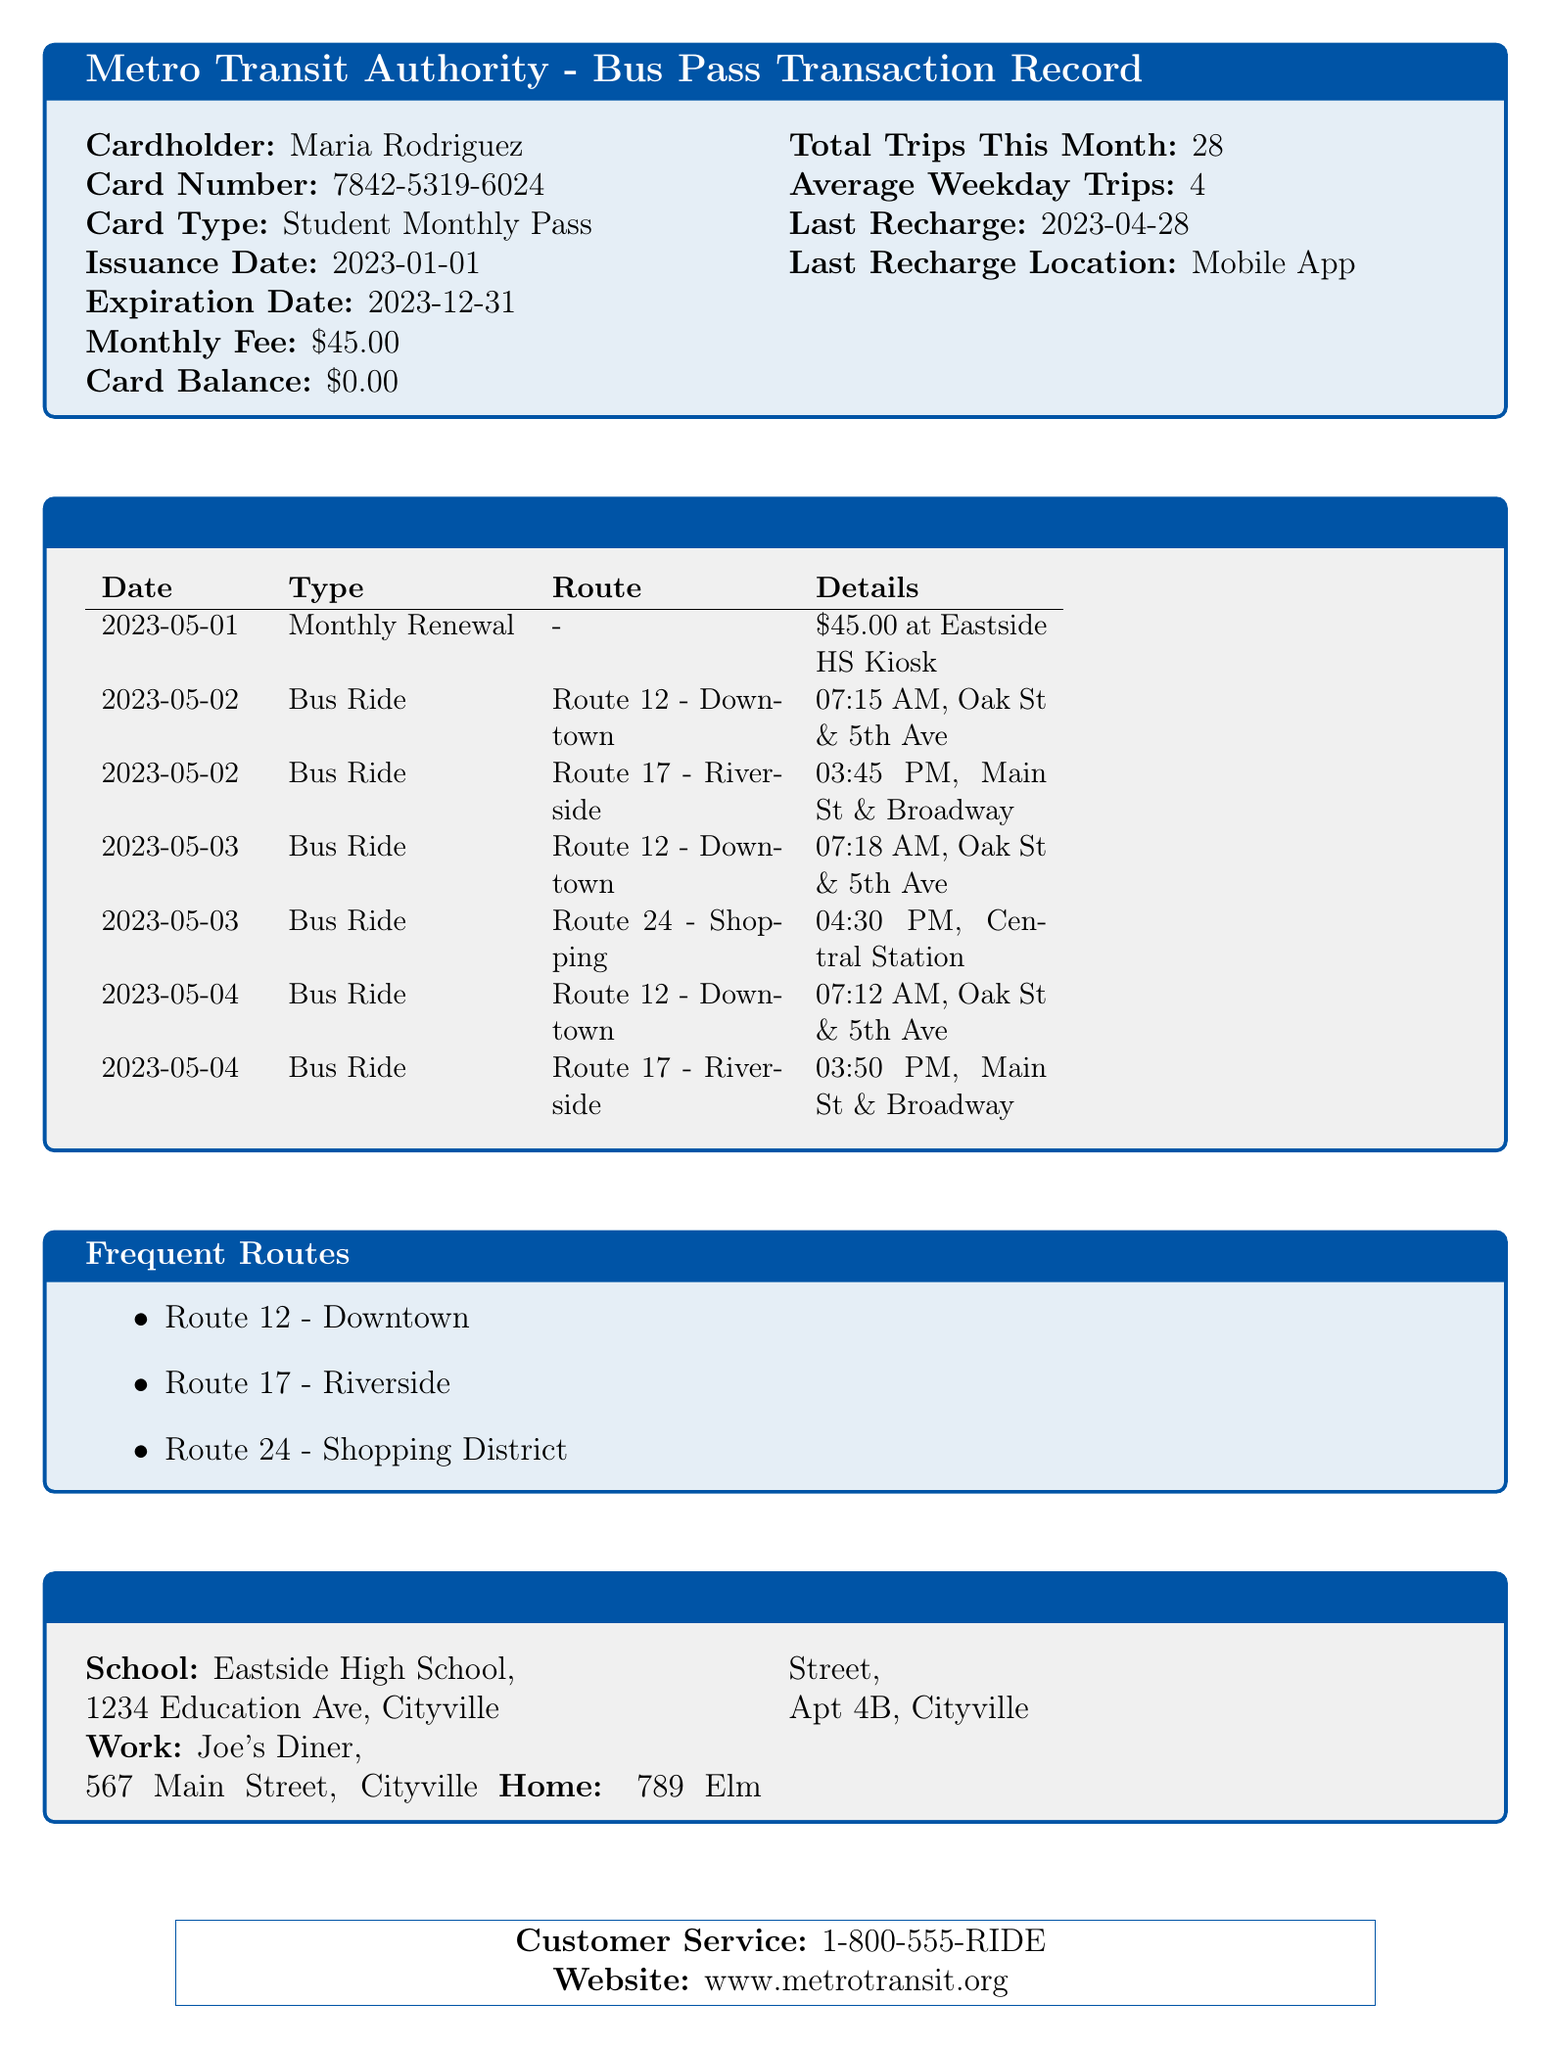what is the cardholder's name? The cardholder's name is listed at the beginning of the document, showing the individual who owns the bus pass.
Answer: Maria Rodriguez what is the monthly fee for the pass? The monthly fee is stated in the financial section of the document, reflecting the cost of the pass.
Answer: $45.00 when was the last recharge made? The last recharge date can be found in the summary box, detailing recent transactions.
Answer: 2023-04-28 how many total trips has Maria taken this month? The total trips this month is summarized in the statistics portion of the document, indicating usage frequency.
Answer: 28 which route is taken to get to school? The route to get to school can be inferred from the frequent routes section of the document that lists the most used routes.
Answer: Route 12 - Downtown what type of card does Maria have? The card type is specifically mentioned in the document, describing the nature of the pass.
Answer: Student Monthly Pass where is Maria's work located? The work address is provided in the important addresses section and specifies Maria's place of employment.
Answer: Joe's Diner, 567 Main Street, Cityville how many average trips does Maria take on weekdays? The average weekday trips are defined in the summary, providing an insight into her commuting habits.
Answer: 4 what was the location of the last recharge? The last recharge location indicates where Maria added funds to her bus card and is indicated in the summary box.
Answer: Mobile App 